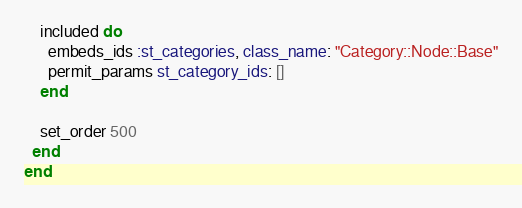Convert code to text. <code><loc_0><loc_0><loc_500><loc_500><_Ruby_>    included do
      embeds_ids :st_categories, class_name: "Category::Node::Base"
      permit_params st_category_ids: []
    end

    set_order 500
  end
end
</code> 